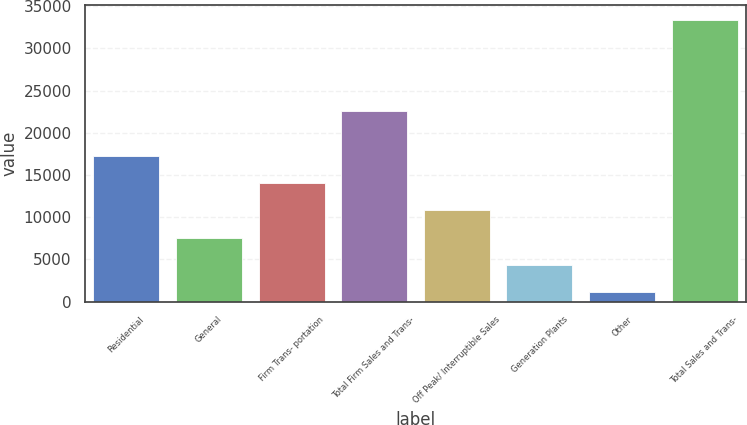<chart> <loc_0><loc_0><loc_500><loc_500><bar_chart><fcel>Residential<fcel>General<fcel>Firm Trans- portation<fcel>Total Firm Sales and Trans-<fcel>Off Peak/ Interruptible Sales<fcel>Generation Plants<fcel>Other<fcel>Total Sales and Trans-<nl><fcel>17278<fcel>7591.6<fcel>14049.2<fcel>22622<fcel>10820.4<fcel>4362.8<fcel>1134<fcel>33422<nl></chart> 